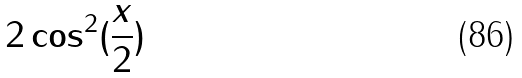<formula> <loc_0><loc_0><loc_500><loc_500>2 \cos ^ { 2 } ( \frac { x } { 2 } )</formula> 